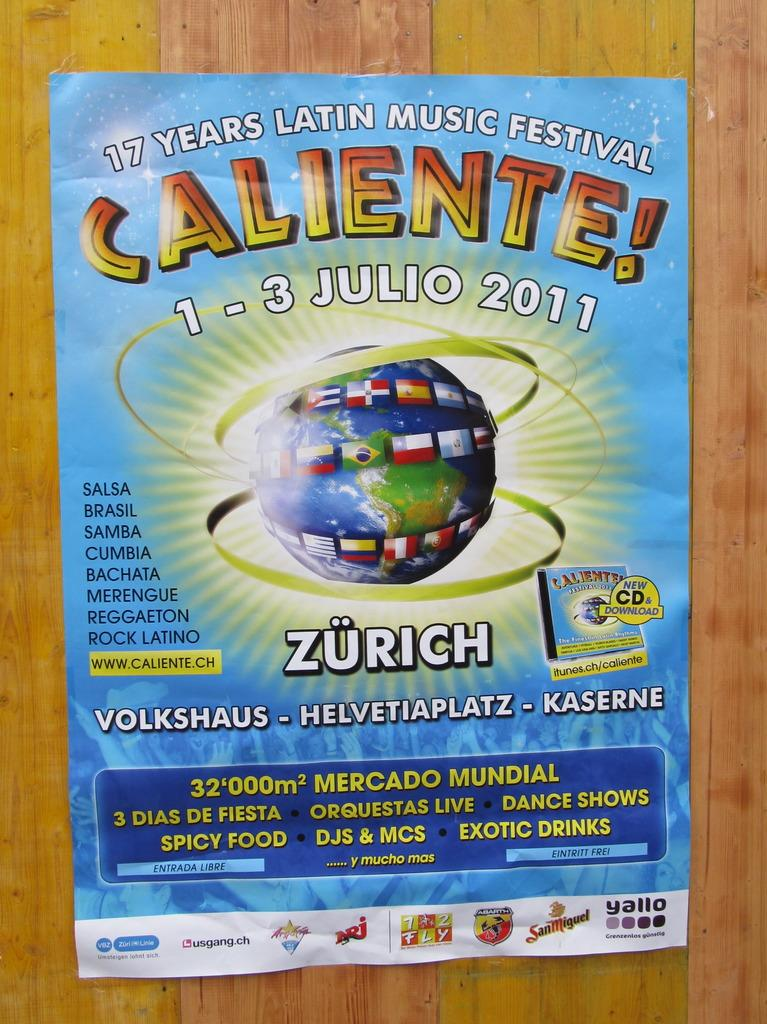<image>
Give a short and clear explanation of the subsequent image. A poster for the latin music festival is on a wooden wall. 